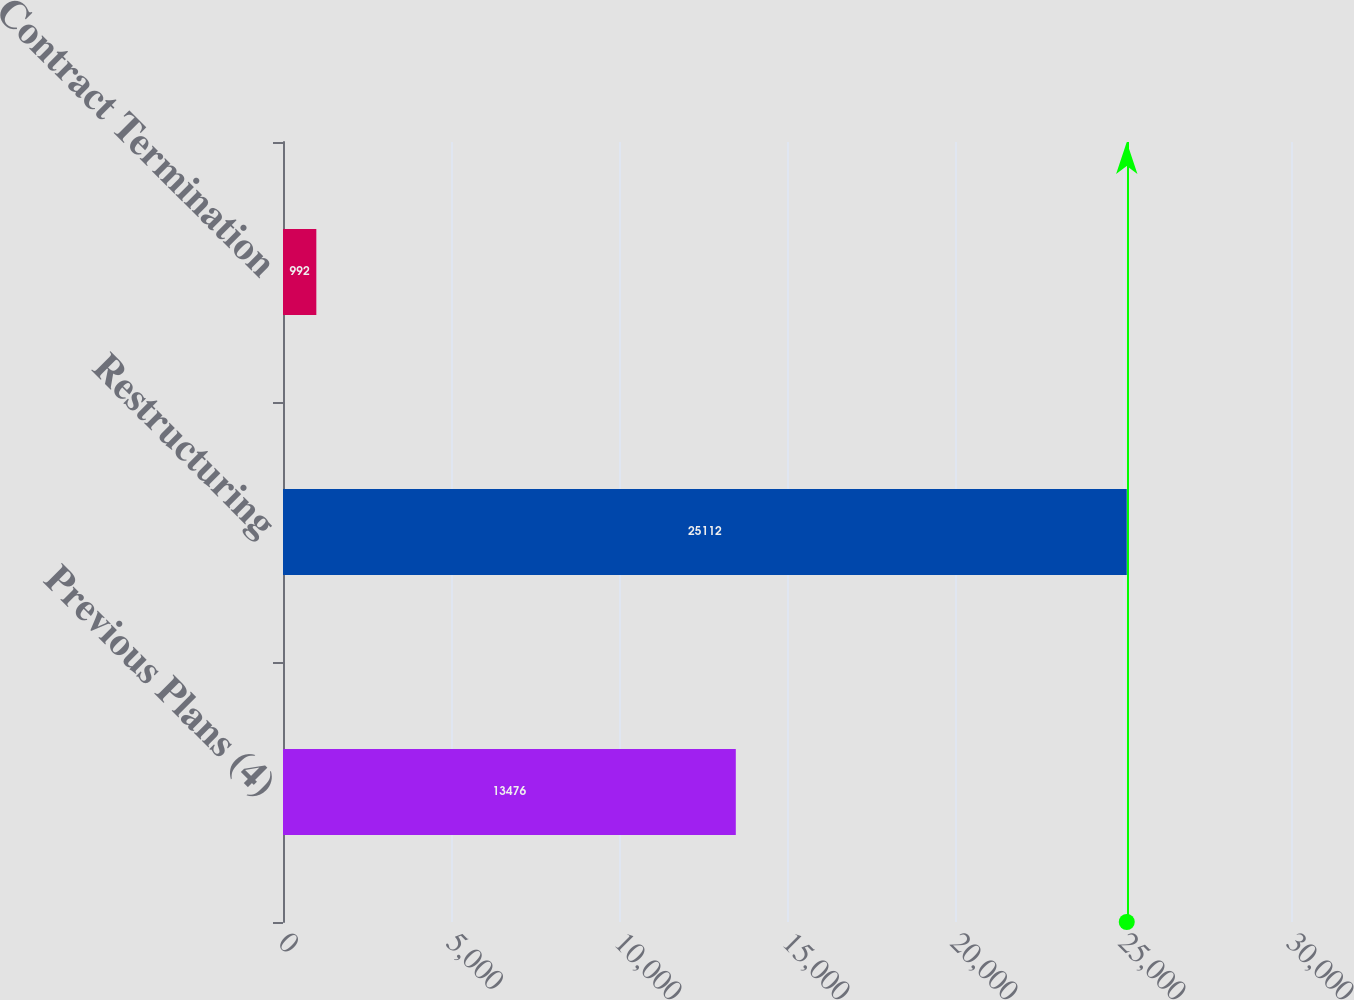<chart> <loc_0><loc_0><loc_500><loc_500><bar_chart><fcel>Previous Plans (4)<fcel>Restructuring<fcel>Contract Termination<nl><fcel>13476<fcel>25112<fcel>992<nl></chart> 